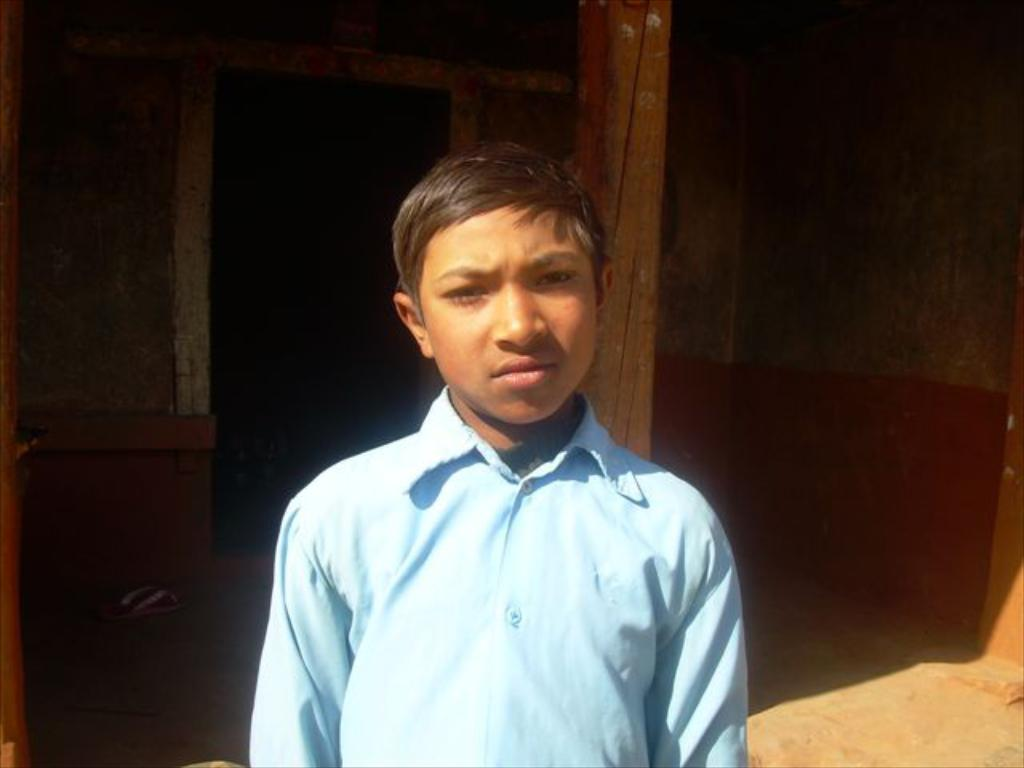What is the man in the image doing? There is no specific action mentioned, but we can see that the man is standing in the image. What is the man wearing in the image? The man is wearing a blue shirt in the image. What can be seen in the image besides the man? There is a wooden pillar, a small house in the background, and footwear visible in the image. What type of crime is being committed in the image? There is no indication of any crime being committed in the image. How does the man mark his territory in the image? There is: There is no mention of marking territory in the image. 